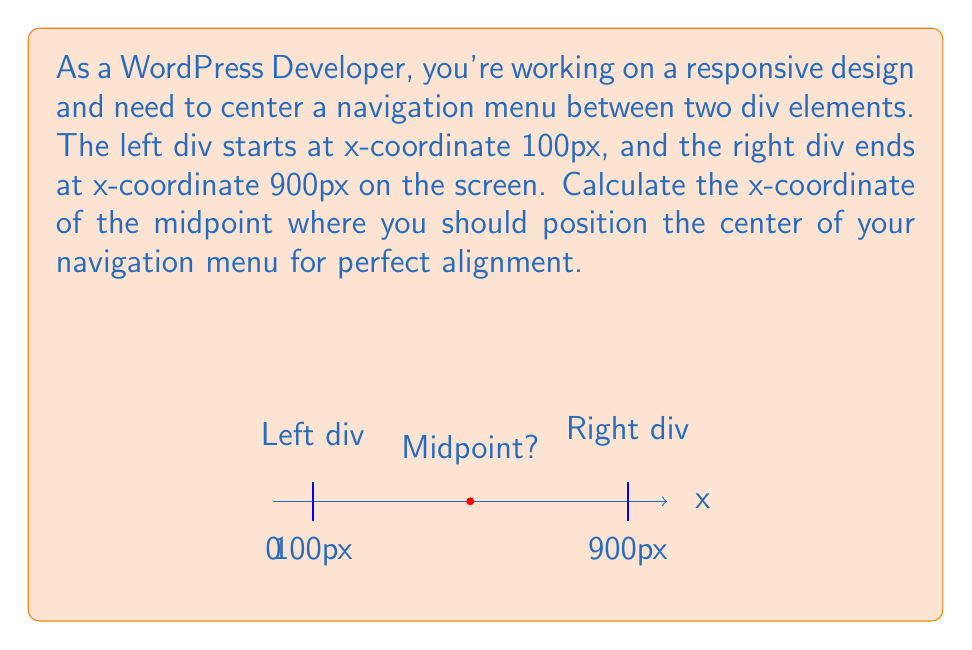Can you solve this math problem? To find the midpoint between two points on a coordinate system, we can use the midpoint formula:

$$ \text{Midpoint} = \frac{x_1 + x_2}{2} $$

Where $x_1$ is the x-coordinate of the first point and $x_2$ is the x-coordinate of the second point.

In this case:
$x_1 = 100$ (left div start)
$x_2 = 900$ (right div end)

Plugging these values into the formula:

$$ \text{Midpoint} = \frac{100 + 900}{2} $$

$$ \text{Midpoint} = \frac{1000}{2} $$

$$ \text{Midpoint} = 500 $$

Therefore, the x-coordinate of the midpoint where you should position the center of your navigation menu is 500px.
Answer: 500px 